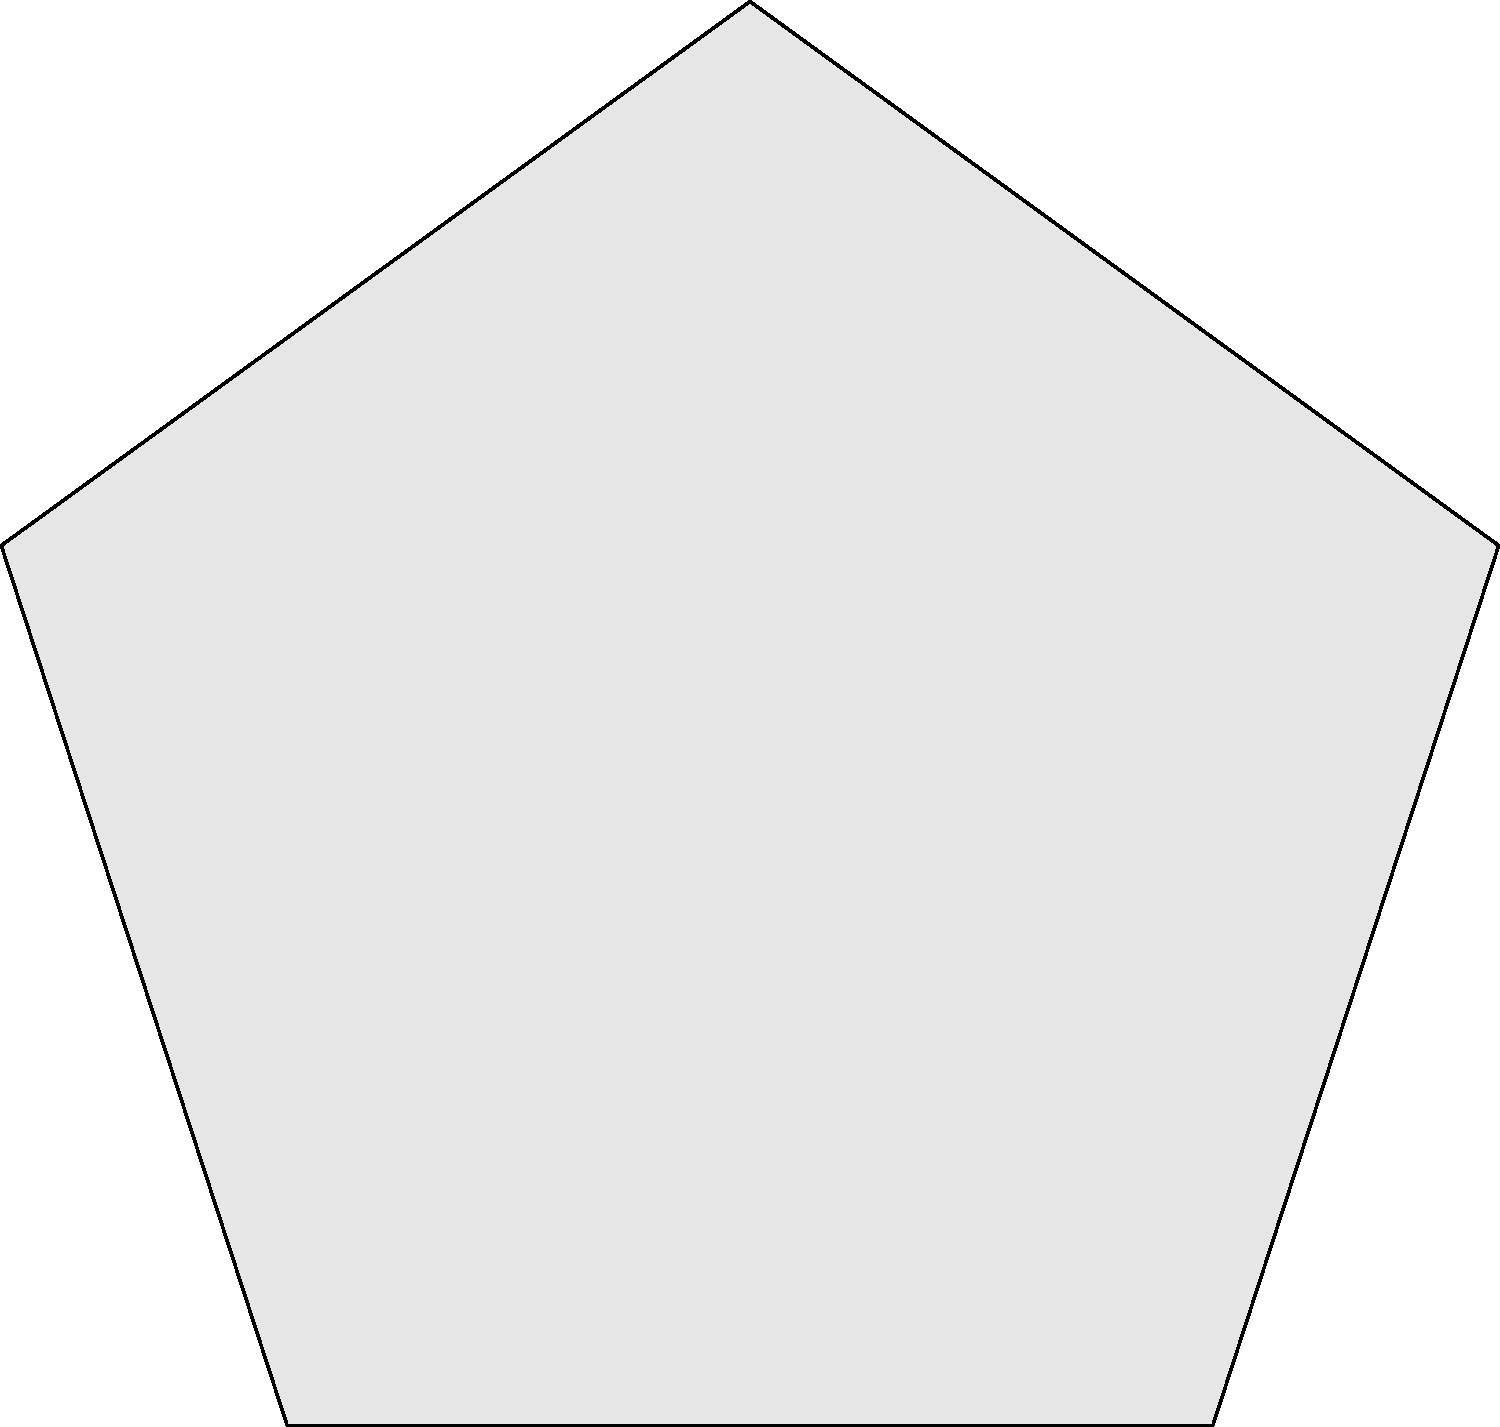In the image above, you can see an alien spacecraft encountered by the Robinson family in their latest adventure. The Jupiter 2 is shown for scale. If the Jupiter 2 has a diameter of 60 meters, estimate the length of one side of the pentagonal alien spacecraft to the nearest 10 meters. Let's approach this step-by-step:

1. First, we need to establish the scale of the image. We're told that the Jupiter 2 has a diameter of 60 meters.

2. In the image, we can see that the scale bar represents 50 meters. This will help us relate the size of the spacecraft to real-world measurements.

3. Visually, we can estimate that the Jupiter 2 is about the same size as the scale bar. This confirms that the scale is consistent with the given information.

4. Now, let's look at the alien spacecraft. We can see that one side of the pentagonal shape is approximately 3 times the diameter of the Jupiter 2.

5. If the Jupiter 2 has a diameter of 60 meters, then one side of the alien spacecraft is approximately:

   $3 \times 60 \text{ meters} = 180 \text{ meters}$

6. The question asks for the estimate to the nearest 10 meters, so we can round 180 meters to 180 meters.

This estimation method is similar to what the Robinsons might use when encountering new alien technology in their adventures!
Answer: 180 meters 